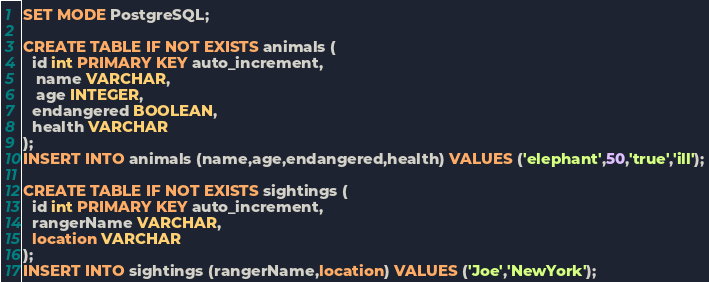Convert code to text. <code><loc_0><loc_0><loc_500><loc_500><_SQL_>SET MODE PostgreSQL;

CREATE TABLE IF NOT EXISTS animals (
  id int PRIMARY KEY auto_increment,
   name VARCHAR,
   age INTEGER,
  endangered BOOLEAN,
  health VARCHAR
);
INSERT INTO animals (name,age,endangered,health) VALUES ('elephant',50,'true','ill');

CREATE TABLE IF NOT EXISTS sightings (
  id int PRIMARY KEY auto_increment,
  rangerName VARCHAR,
  location VARCHAR
);
INSERT INTO sightings (rangerName,location) VALUES ('Joe','NewYork');</code> 